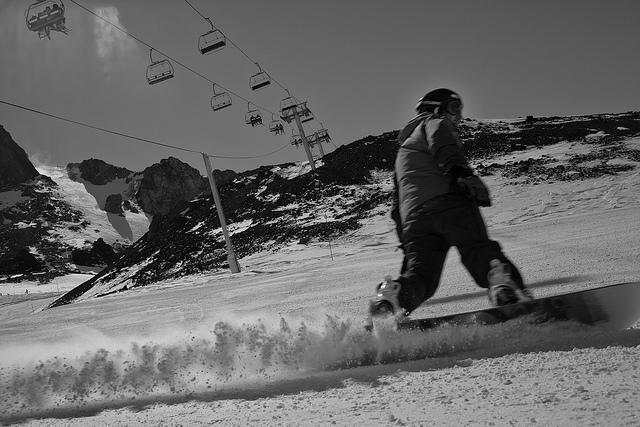How many people are snowboarding?
Give a very brief answer. 1. How many people are on the chairlift?
Give a very brief answer. 8. 